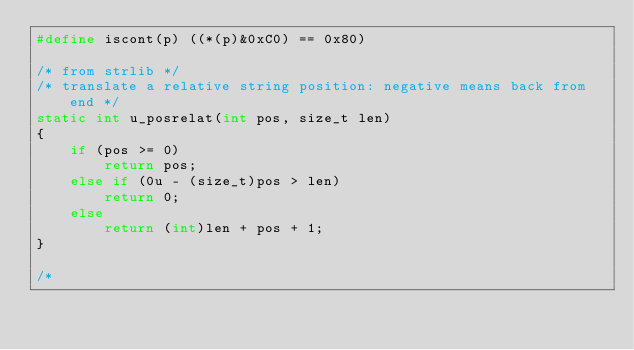<code> <loc_0><loc_0><loc_500><loc_500><_C_>#define iscont(p) ((*(p)&0xC0) == 0x80)

/* from strlib */
/* translate a relative string position: negative means back from end */
static int u_posrelat(int pos, size_t len)
{
    if (pos >= 0)
        return pos;
    else if (0u - (size_t)pos > len)
        return 0;
    else
        return (int)len + pos + 1;
}

/*</code> 